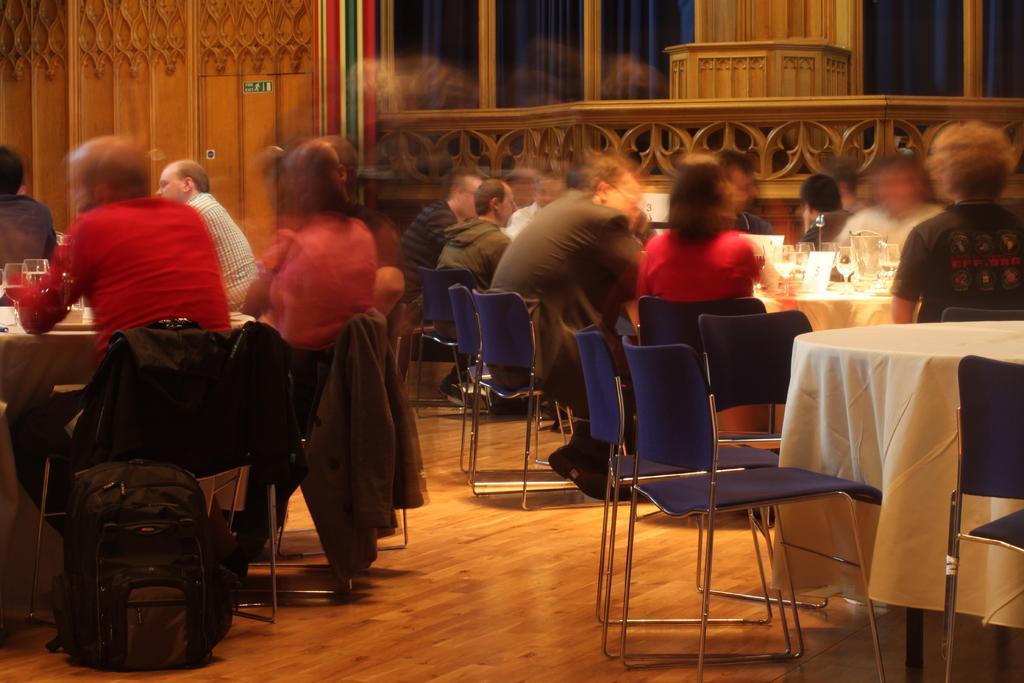Could you give a brief overview of what you see in this image? This picture There are a group of people sitting and there are some tables and chairs in front of them with some wine glasses, water glasses, food, and there is a bag kept on the floor which is made of wooden. There is a empty table and empty chairs here and in a backdrop there is a wall and there is a window 